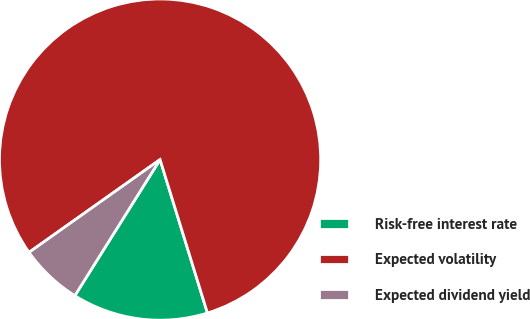Convert chart to OTSL. <chart><loc_0><loc_0><loc_500><loc_500><pie_chart><fcel>Risk-free interest rate<fcel>Expected volatility<fcel>Expected dividend yield<nl><fcel>13.67%<fcel>80.04%<fcel>6.29%<nl></chart> 